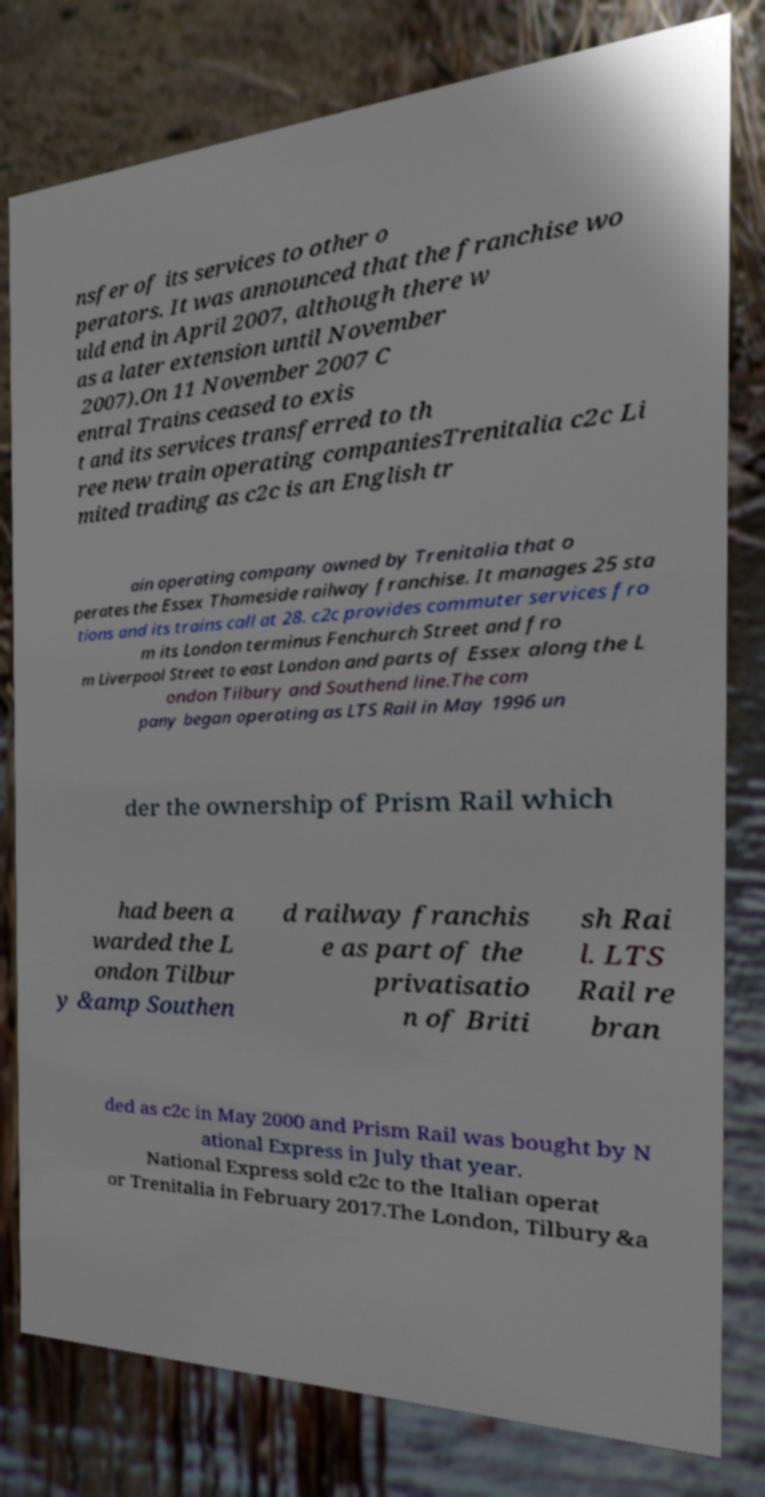Please read and relay the text visible in this image. What does it say? nsfer of its services to other o perators. It was announced that the franchise wo uld end in April 2007, although there w as a later extension until November 2007).On 11 November 2007 C entral Trains ceased to exis t and its services transferred to th ree new train operating companiesTrenitalia c2c Li mited trading as c2c is an English tr ain operating company owned by Trenitalia that o perates the Essex Thameside railway franchise. It manages 25 sta tions and its trains call at 28. c2c provides commuter services fro m its London terminus Fenchurch Street and fro m Liverpool Street to east London and parts of Essex along the L ondon Tilbury and Southend line.The com pany began operating as LTS Rail in May 1996 un der the ownership of Prism Rail which had been a warded the L ondon Tilbur y &amp Southen d railway franchis e as part of the privatisatio n of Briti sh Rai l. LTS Rail re bran ded as c2c in May 2000 and Prism Rail was bought by N ational Express in July that year. National Express sold c2c to the Italian operat or Trenitalia in February 2017.The London, Tilbury &a 